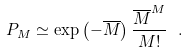Convert formula to latex. <formula><loc_0><loc_0><loc_500><loc_500>P _ { M } \simeq \exp \left ( - \overline { M } \right ) \frac { \overline { M } ^ { M } } { M ! } \ .</formula> 